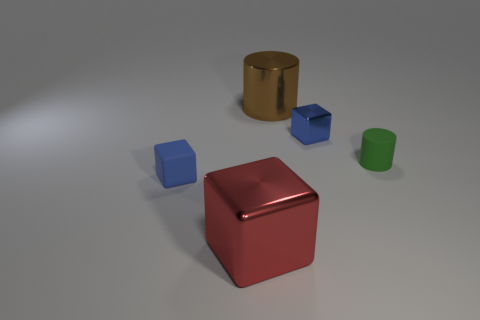Describe the surface the objects are resting on. The objects appear to be resting on a smooth, matte surface, which has a slightly reflective quality. The gentle shadows and faint reflections help give a sense of the texture and form of the surface, likely a synthetic or treated material that's common in interior settings. 